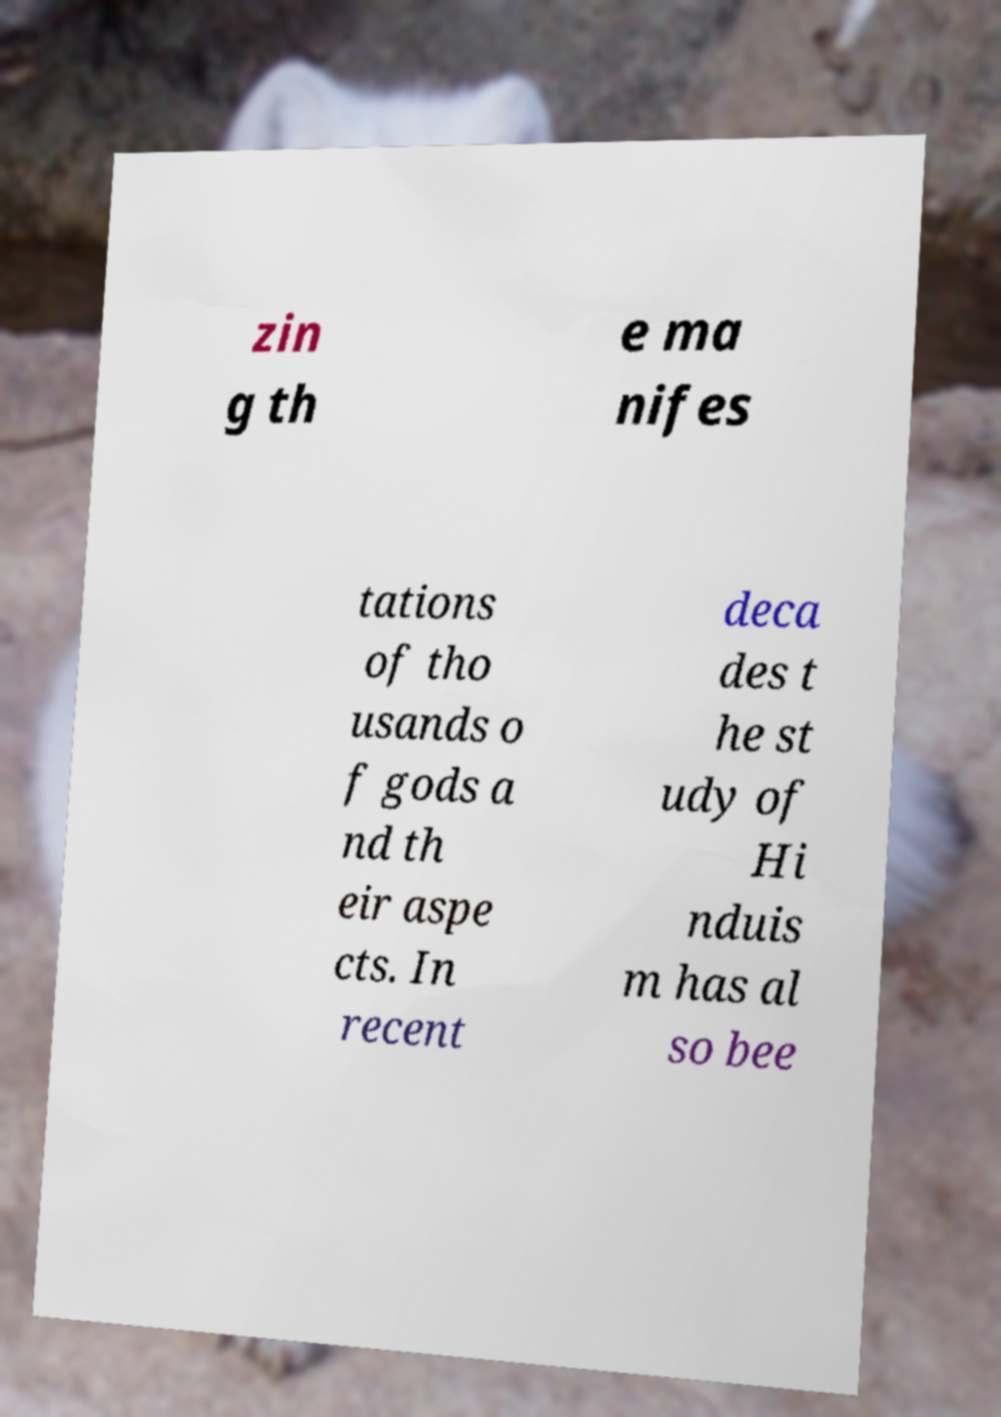There's text embedded in this image that I need extracted. Can you transcribe it verbatim? zin g th e ma nifes tations of tho usands o f gods a nd th eir aspe cts. In recent deca des t he st udy of Hi nduis m has al so bee 